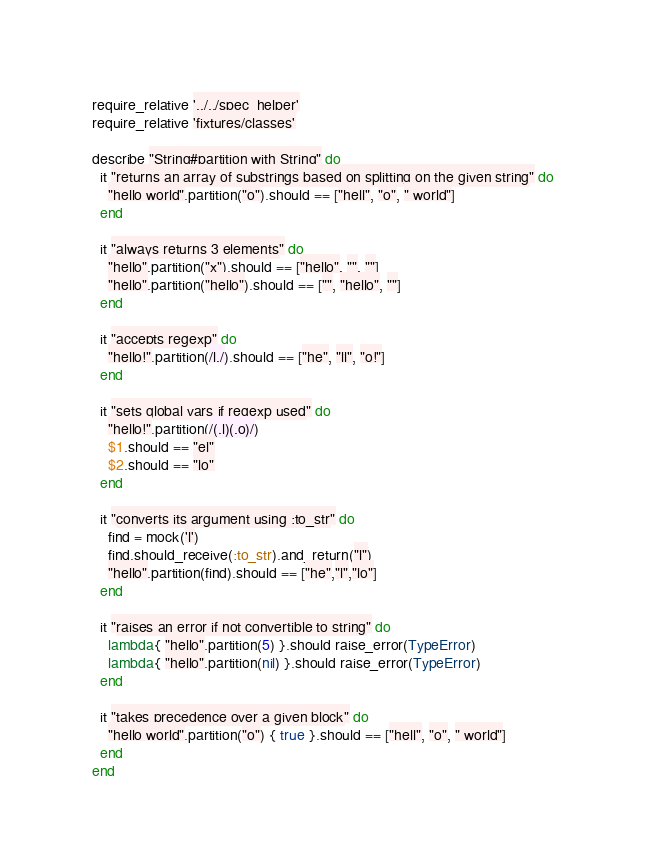<code> <loc_0><loc_0><loc_500><loc_500><_Ruby_>require_relative '../../spec_helper'
require_relative 'fixtures/classes'

describe "String#partition with String" do
  it "returns an array of substrings based on splitting on the given string" do
    "hello world".partition("o").should == ["hell", "o", " world"]
  end

  it "always returns 3 elements" do
    "hello".partition("x").should == ["hello", "", ""]
    "hello".partition("hello").should == ["", "hello", ""]
  end

  it "accepts regexp" do
    "hello!".partition(/l./).should == ["he", "ll", "o!"]
  end

  it "sets global vars if regexp used" do
    "hello!".partition(/(.l)(.o)/)
    $1.should == "el"
    $2.should == "lo"
  end

  it "converts its argument using :to_str" do
    find = mock('l')
    find.should_receive(:to_str).and_return("l")
    "hello".partition(find).should == ["he","l","lo"]
  end

  it "raises an error if not convertible to string" do
    lambda{ "hello".partition(5) }.should raise_error(TypeError)
    lambda{ "hello".partition(nil) }.should raise_error(TypeError)
  end

  it "takes precedence over a given block" do
    "hello world".partition("o") { true }.should == ["hell", "o", " world"]
  end
end
</code> 